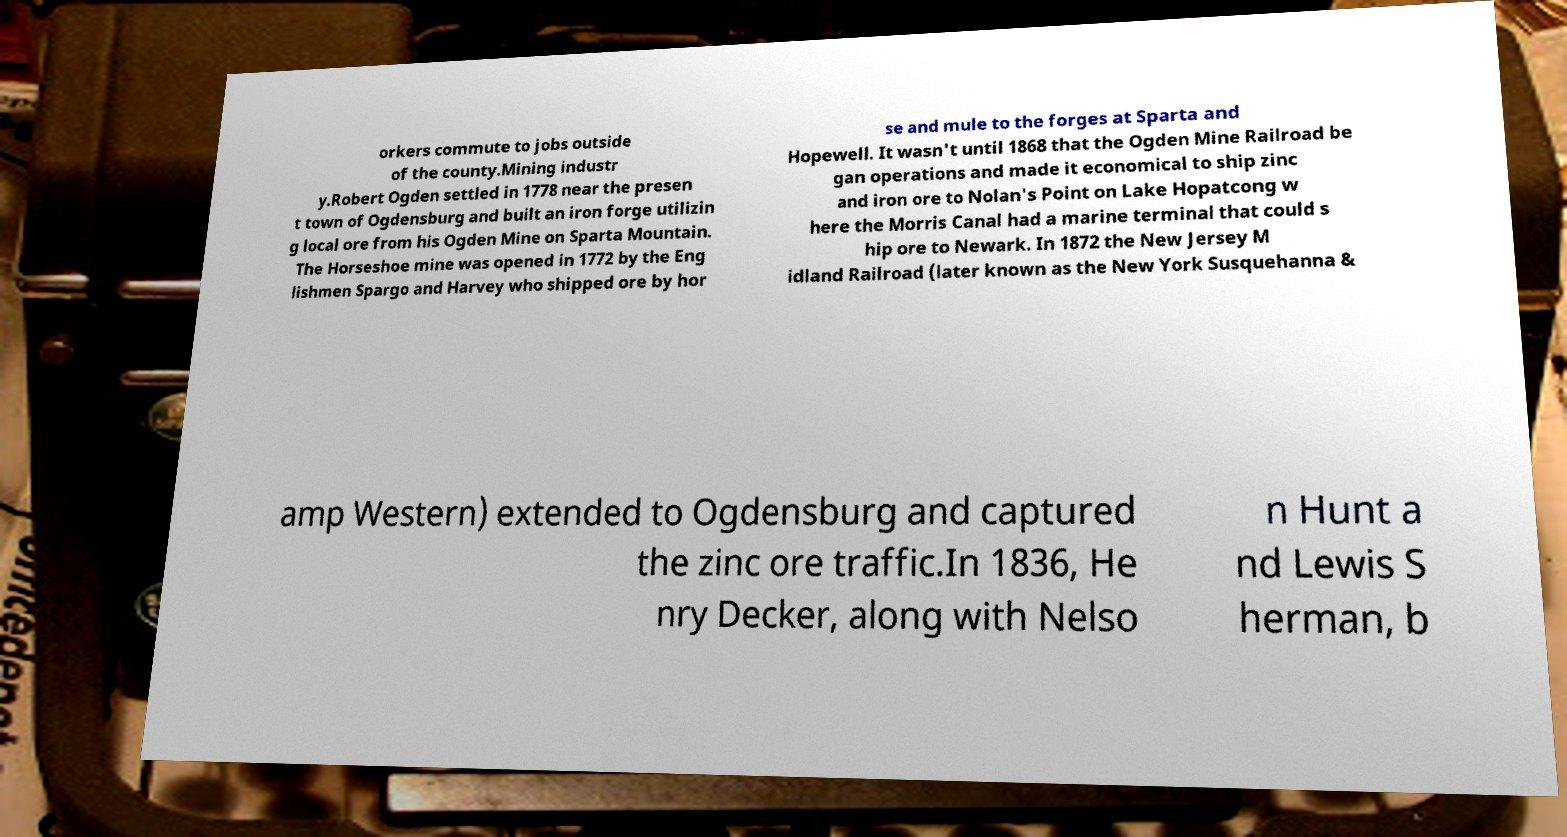For documentation purposes, I need the text within this image transcribed. Could you provide that? orkers commute to jobs outside of the county.Mining industr y.Robert Ogden settled in 1778 near the presen t town of Ogdensburg and built an iron forge utilizin g local ore from his Ogden Mine on Sparta Mountain. The Horseshoe mine was opened in 1772 by the Eng lishmen Spargo and Harvey who shipped ore by hor se and mule to the forges at Sparta and Hopewell. It wasn't until 1868 that the Ogden Mine Railroad be gan operations and made it economical to ship zinc and iron ore to Nolan's Point on Lake Hopatcong w here the Morris Canal had a marine terminal that could s hip ore to Newark. In 1872 the New Jersey M idland Railroad (later known as the New York Susquehanna & amp Western) extended to Ogdensburg and captured the zinc ore traffic.In 1836, He nry Decker, along with Nelso n Hunt a nd Lewis S herman, b 